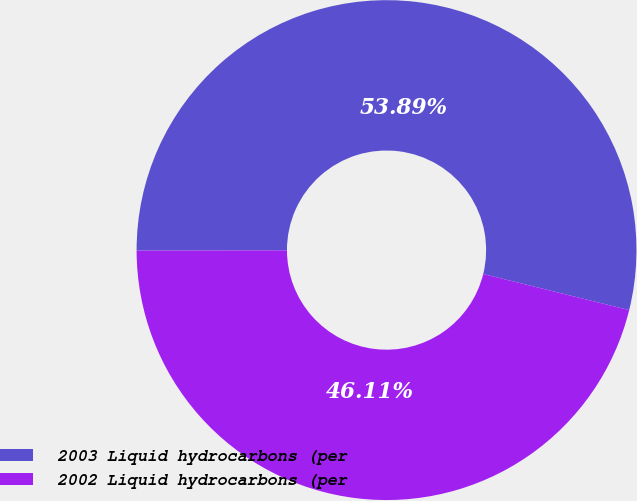Convert chart to OTSL. <chart><loc_0><loc_0><loc_500><loc_500><pie_chart><fcel>2003 Liquid hydrocarbons (per<fcel>2002 Liquid hydrocarbons (per<nl><fcel>53.89%<fcel>46.11%<nl></chart> 